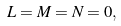Convert formula to latex. <formula><loc_0><loc_0><loc_500><loc_500>L = M = N = 0 ,</formula> 